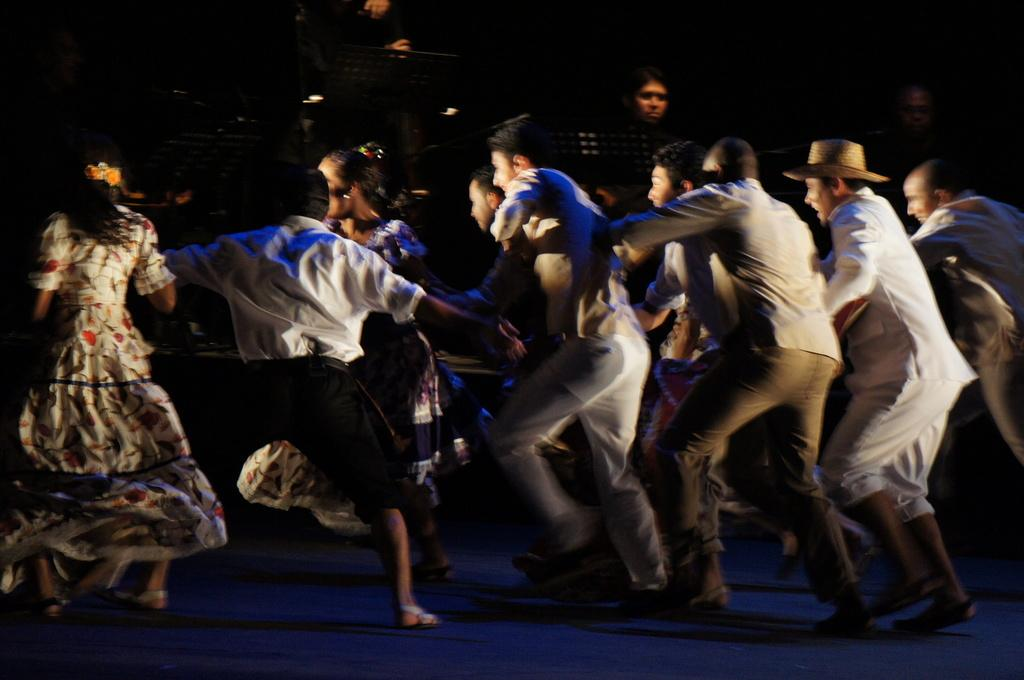What are the people in the image doing? There is a group of people dancing in the image. Can you describe the other people in the image? There is a group of people at the back of the image. What objects are present in the image that might be used for performances? There are stands and microphones in the image. What is the surface that the people are standing on? There is a floor visible in the image. Where is the nest located in the image? There is no nest present in the image. What type of net can be seen in the image? There is no net present in the image. 